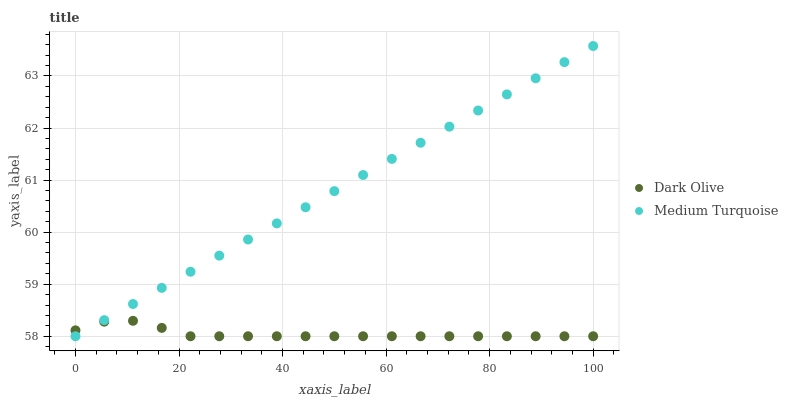Does Dark Olive have the minimum area under the curve?
Answer yes or no. Yes. Does Medium Turquoise have the maximum area under the curve?
Answer yes or no. Yes. Does Medium Turquoise have the minimum area under the curve?
Answer yes or no. No. Is Medium Turquoise the smoothest?
Answer yes or no. Yes. Is Dark Olive the roughest?
Answer yes or no. Yes. Is Medium Turquoise the roughest?
Answer yes or no. No. Does Dark Olive have the lowest value?
Answer yes or no. Yes. Does Medium Turquoise have the highest value?
Answer yes or no. Yes. Does Medium Turquoise intersect Dark Olive?
Answer yes or no. Yes. Is Medium Turquoise less than Dark Olive?
Answer yes or no. No. Is Medium Turquoise greater than Dark Olive?
Answer yes or no. No. 